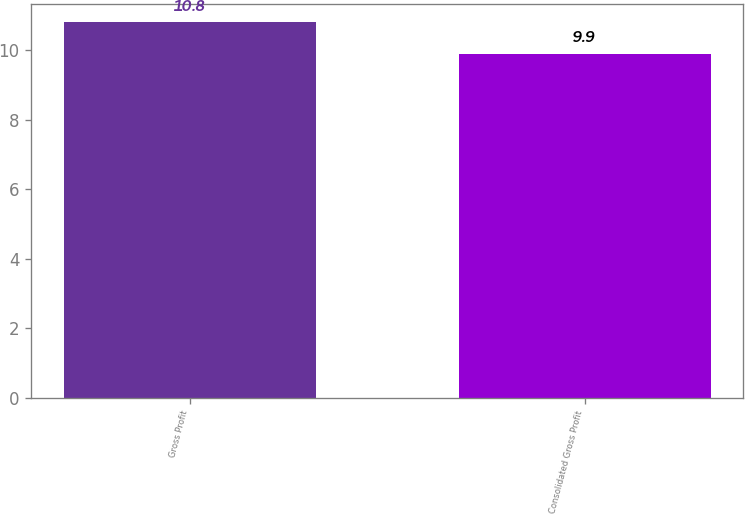Convert chart. <chart><loc_0><loc_0><loc_500><loc_500><bar_chart><fcel>Gross Profit<fcel>Consolidated Gross Profit<nl><fcel>10.8<fcel>9.9<nl></chart> 